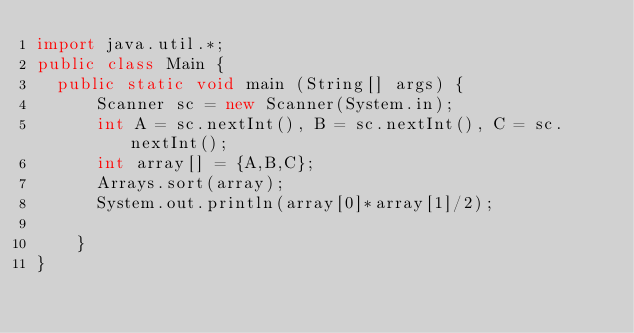Convert code to text. <code><loc_0><loc_0><loc_500><loc_500><_Java_>import java.util.*;
public class Main {
	public static void main (String[] args) {
      Scanner sc = new Scanner(System.in);
      int A = sc.nextInt(), B = sc.nextInt(), C = sc.nextInt();
      int array[] = {A,B,C};
      Arrays.sort(array);
      System.out.println(array[0]*array[1]/2);
      
    }
}</code> 